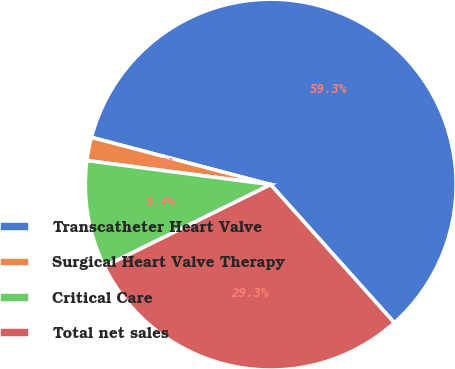Convert chart to OTSL. <chart><loc_0><loc_0><loc_500><loc_500><pie_chart><fcel>Transcatheter Heart Valve<fcel>Surgical Heart Valve Therapy<fcel>Critical Care<fcel>Total net sales<nl><fcel>59.28%<fcel>2.03%<fcel>9.36%<fcel>29.33%<nl></chart> 